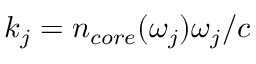Convert formula to latex. <formula><loc_0><loc_0><loc_500><loc_500>k _ { j } = n _ { c o r e } ( \omega _ { j } ) \omega _ { j } / c</formula> 